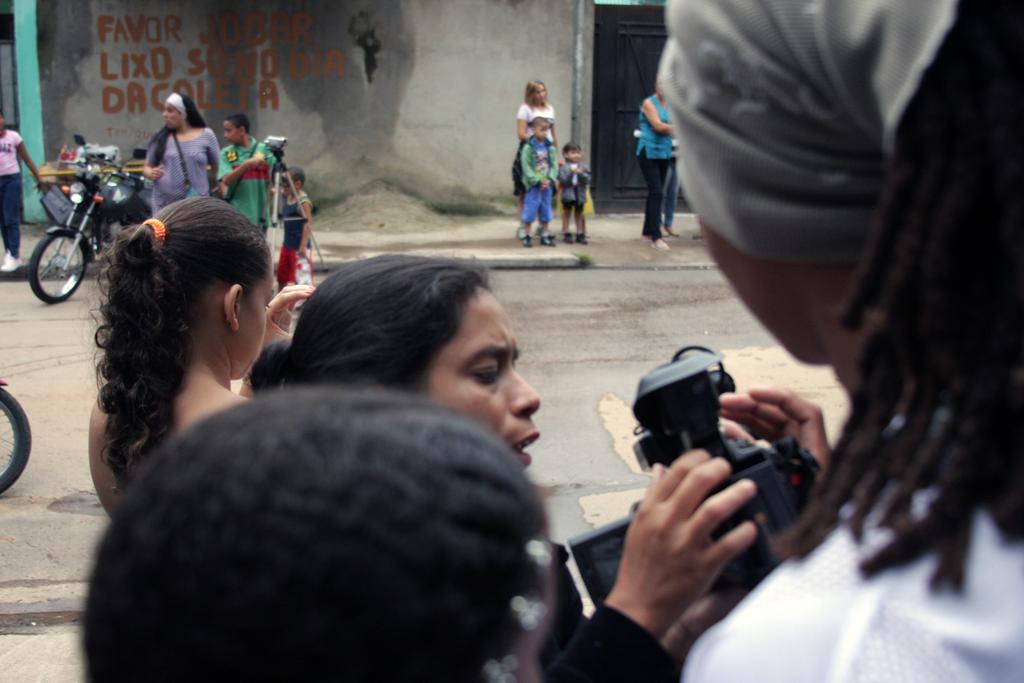Describe this image in one or two sentences. In this image there are a group of persons standing, the persons are holding an object, there is a road towards the left of the image, there are vehicles on the road, there are objects on the road, there is a gate towards the top of the image, there is a wall towards the top of the image, there is text on the wall. 